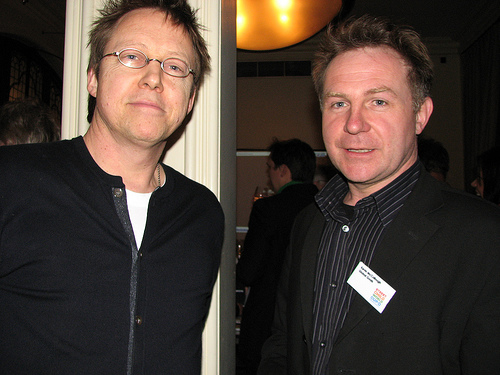<image>
Can you confirm if the name tag is to the right of the glasses? Yes. From this viewpoint, the name tag is positioned to the right side relative to the glasses. 